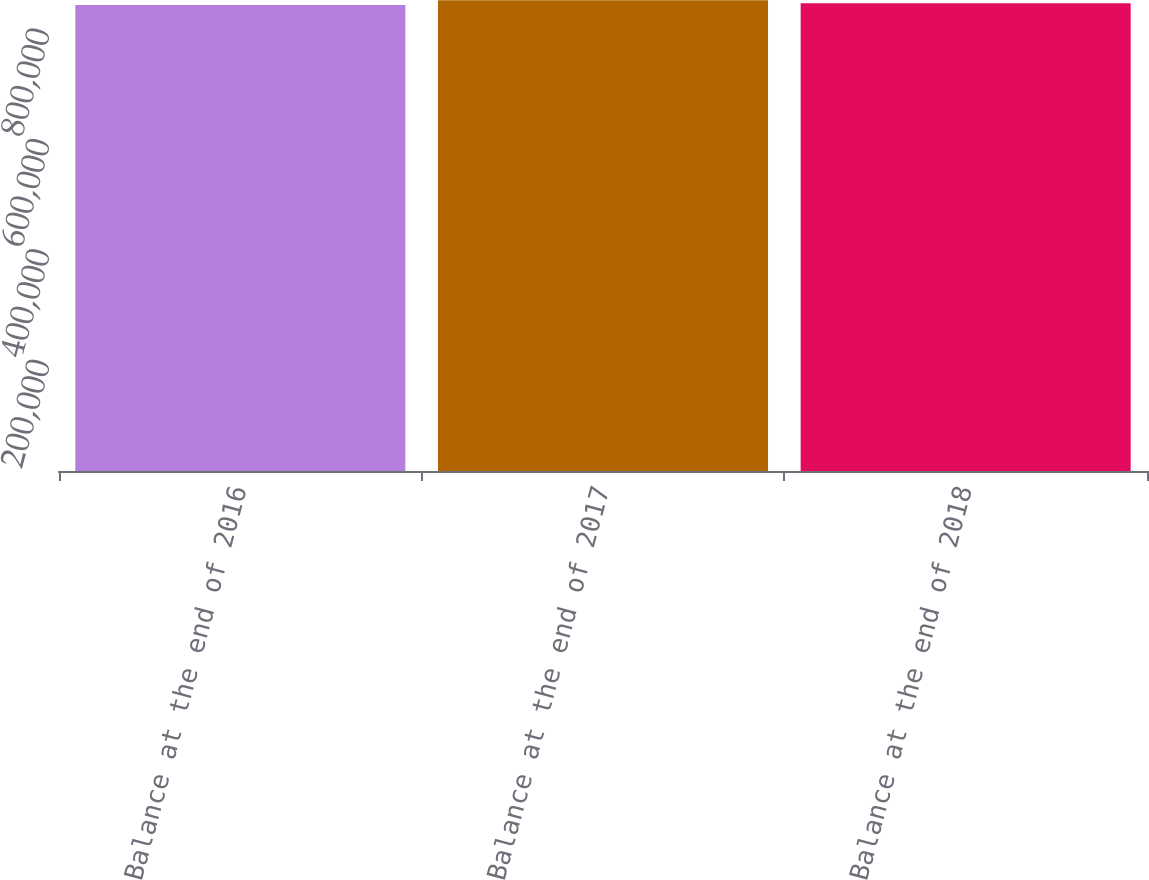Convert chart. <chart><loc_0><loc_0><loc_500><loc_500><bar_chart><fcel>Balance at the end of 2016<fcel>Balance at the end of 2017<fcel>Balance at the end of 2018<nl><fcel>844200<fcel>853005<fcel>847544<nl></chart> 